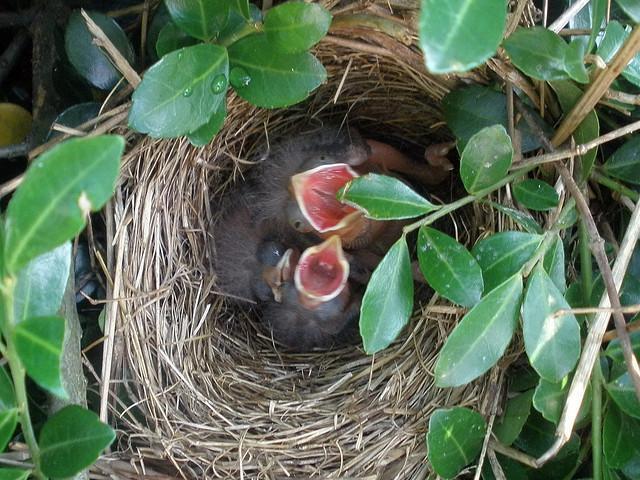Why are their mouths open?
Make your selection and explain in format: 'Answer: answer
Rationale: rationale.'
Options: Talking, drinking, hunting, hungry. Answer: hungry.
Rationale: The birds want the mother brood to drop food in their mouths. 